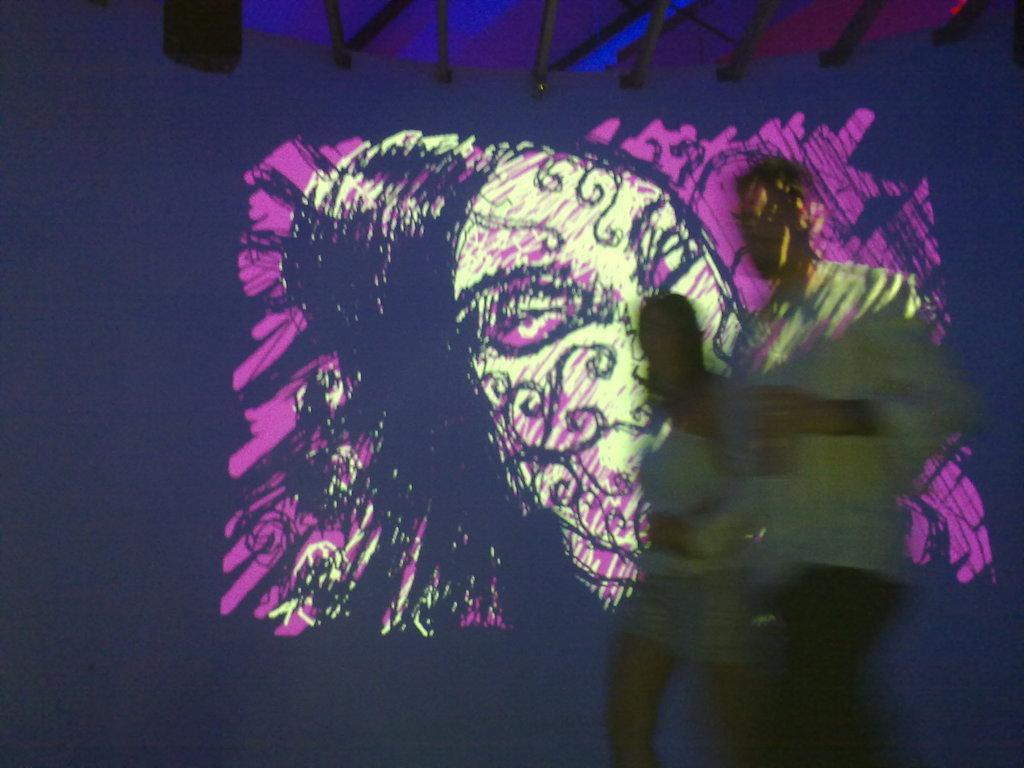In one or two sentences, can you explain what this image depicts? In the picture we can see a painting on the screen and on it we can see a shadow of the two people. 